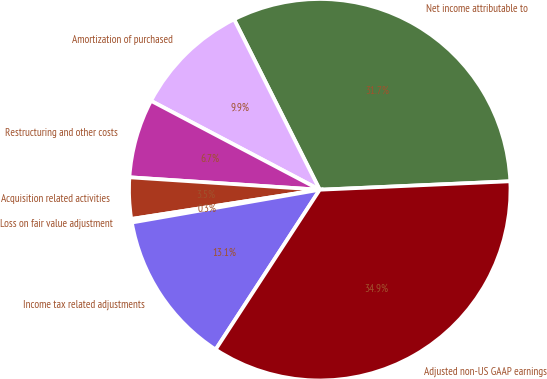<chart> <loc_0><loc_0><loc_500><loc_500><pie_chart><fcel>Net income attributable to<fcel>Amortization of purchased<fcel>Restructuring and other costs<fcel>Acquisition related activities<fcel>Loss on fair value adjustment<fcel>Income tax related adjustments<fcel>Adjusted non-US GAAP earnings<nl><fcel>31.71%<fcel>9.87%<fcel>6.68%<fcel>3.49%<fcel>0.3%<fcel>13.06%<fcel>34.9%<nl></chart> 